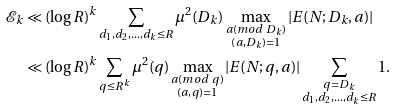<formula> <loc_0><loc_0><loc_500><loc_500>\mathcal { E } _ { k } & \ll ( \log R ) ^ { k } \sum _ { d _ { 1 } , d _ { 2 } , \dots , d _ { k } \leq R } \mu ^ { 2 } ( D _ { k } ) \max _ { \substack { a ( m o d \ D _ { k } ) \\ ( a , D _ { k } ) = 1 } } | E ( N ; D _ { k } , a ) | \\ & \ll ( \log R ) ^ { k } \sum _ { q \leq R ^ { k } } \mu ^ { 2 } ( q ) \max _ { \substack { a ( m o d \ q ) \\ ( a , q ) = 1 } } | E ( N ; q , a ) | \sum _ { \substack { q = D _ { k } \\ d _ { 1 } , d _ { 2 } , \dots , d _ { k } \leq R } } 1 .</formula> 